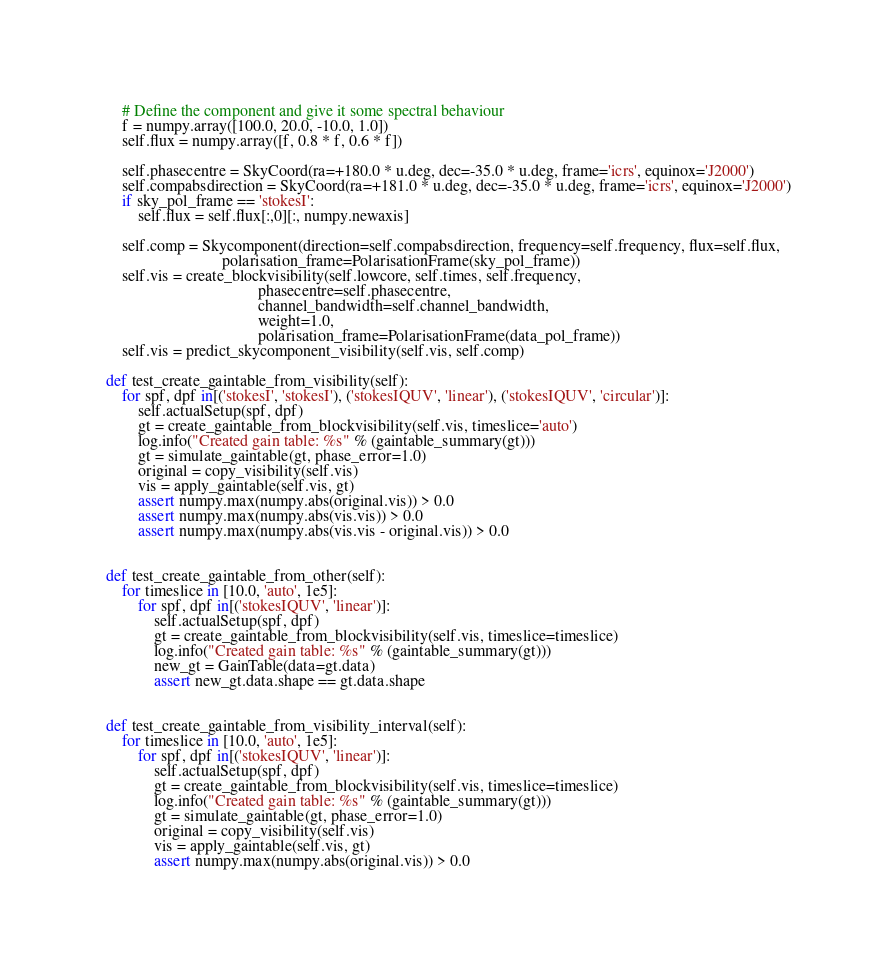Convert code to text. <code><loc_0><loc_0><loc_500><loc_500><_Python_>    
        # Define the component and give it some spectral behaviour
        f = numpy.array([100.0, 20.0, -10.0, 1.0])
        self.flux = numpy.array([f, 0.8 * f, 0.6 * f])
    
        self.phasecentre = SkyCoord(ra=+180.0 * u.deg, dec=-35.0 * u.deg, frame='icrs', equinox='J2000')
        self.compabsdirection = SkyCoord(ra=+181.0 * u.deg, dec=-35.0 * u.deg, frame='icrs', equinox='J2000')
        if sky_pol_frame == 'stokesI':
            self.flux = self.flux[:,0][:, numpy.newaxis]
            
        self.comp = Skycomponent(direction=self.compabsdirection, frequency=self.frequency, flux=self.flux,
                                 polarisation_frame=PolarisationFrame(sky_pol_frame))
        self.vis = create_blockvisibility(self.lowcore, self.times, self.frequency,
                                          phasecentre=self.phasecentre,
                                          channel_bandwidth=self.channel_bandwidth,
                                          weight=1.0,
                                          polarisation_frame=PolarisationFrame(data_pol_frame))
        self.vis = predict_skycomponent_visibility(self.vis, self.comp)

    def test_create_gaintable_from_visibility(self):
        for spf, dpf in[('stokesI', 'stokesI'), ('stokesIQUV', 'linear'), ('stokesIQUV', 'circular')]:
            self.actualSetup(spf, dpf)
            gt = create_gaintable_from_blockvisibility(self.vis, timeslice='auto')
            log.info("Created gain table: %s" % (gaintable_summary(gt)))
            gt = simulate_gaintable(gt, phase_error=1.0)
            original = copy_visibility(self.vis)
            vis = apply_gaintable(self.vis, gt)
            assert numpy.max(numpy.abs(original.vis)) > 0.0
            assert numpy.max(numpy.abs(vis.vis)) > 0.0
            assert numpy.max(numpy.abs(vis.vis - original.vis)) > 0.0


    def test_create_gaintable_from_other(self):
        for timeslice in [10.0, 'auto', 1e5]:
            for spf, dpf in[('stokesIQUV', 'linear')]:
                self.actualSetup(spf, dpf)
                gt = create_gaintable_from_blockvisibility(self.vis, timeslice=timeslice)
                log.info("Created gain table: %s" % (gaintable_summary(gt)))
                new_gt = GainTable(data=gt.data)
                assert new_gt.data.shape == gt.data.shape


    def test_create_gaintable_from_visibility_interval(self):
        for timeslice in [10.0, 'auto', 1e5]:
            for spf, dpf in[('stokesIQUV', 'linear')]:
                self.actualSetup(spf, dpf)
                gt = create_gaintable_from_blockvisibility(self.vis, timeslice=timeslice)
                log.info("Created gain table: %s" % (gaintable_summary(gt)))
                gt = simulate_gaintable(gt, phase_error=1.0)
                original = copy_visibility(self.vis)
                vis = apply_gaintable(self.vis, gt)
                assert numpy.max(numpy.abs(original.vis)) > 0.0</code> 